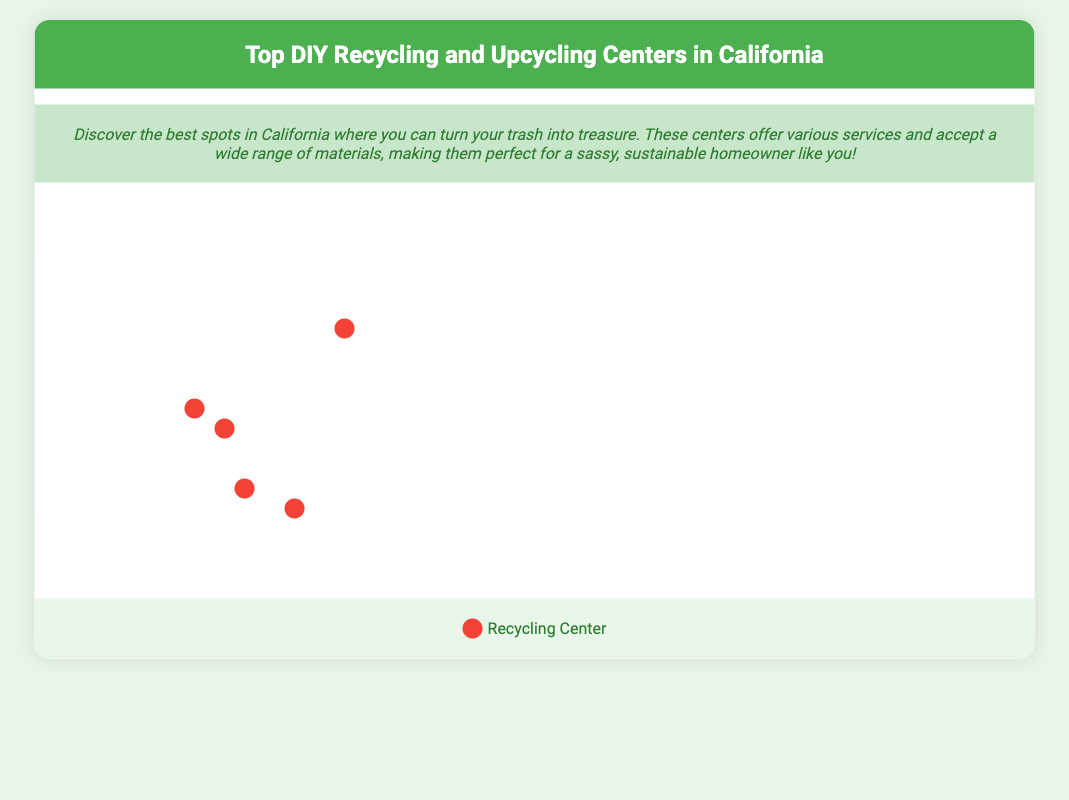What is the location of CalRecycle? CalRecycle is located in Sacramento, CA, which is explicitly mentioned in the document.
Answer: Sacramento, CA What materials does Urban Ore accept? The accepted materials for Urban Ore include furniture, electronics, metal scraps, appliances, and fixtures, listed directly in the document.
Answer: Furniture, electronics, metal scraps, appliances, fixtures What is the community impact of The Long Beach Recycled Materials Yard? The Long Beach Recycled Materials Yard salvages construction materials and offers them at low cost for DIY projects, which affects sustainability and renovation, as described in the document.
Answer: Salvages construction materials How many recycling centers are highlighted in the infographic? The infographic lists a total of five recycling and upcycling centers in California, which is evident from the map points and information sections provided.
Answer: Five What type of materials does Artist & Craftsman Supply focus on? Artist & Craftsman Supply accepts art supplies, craft materials, textiles, jewelry components, and beads, which are specified in the document.
Answer: Art supplies, craft materials, textiles, jewelry components, beads Which center is located in Oakland? The center located in Oakland, CA, is identified as "Re-Use People of America" in the document.
Answer: Re-Use People of America What color represents Recycling Centers on the legend? The legend indicates that recycling centers are represented by the color red, which is denoted in the color block.
Answer: Red What community impact is associated with Urban Ore? Urban Ore creates a positive environmental impact by reselling reusable items, as mentioned in the information related to the center.
Answer: Diverts resources from landfills 